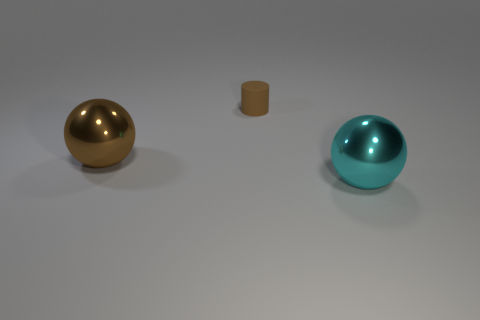What is the color of the metal object that is to the left of the big metallic object that is in front of the large object that is to the left of the big cyan sphere?
Keep it short and to the point. Brown. Are there any other things that are the same color as the matte object?
Your answer should be very brief. Yes. There is another object that is the same color as the small object; what is its shape?
Keep it short and to the point. Sphere. What is the size of the thing that is to the left of the small brown thing?
Your answer should be very brief. Large. There is another thing that is the same size as the cyan metal thing; what is its shape?
Your answer should be compact. Sphere. Does the big ball that is on the right side of the small brown object have the same material as the brown object to the right of the large brown object?
Your answer should be very brief. No. There is a large thing that is on the left side of the cyan sphere that is right of the brown rubber object; what is its material?
Provide a short and direct response. Metal. What is the size of the ball that is on the right side of the large metal thing that is left of the metallic object to the right of the brown shiny ball?
Provide a short and direct response. Large. Do the brown matte cylinder and the brown metal object have the same size?
Provide a short and direct response. No. Does the big object to the right of the small object have the same shape as the large metallic object that is left of the tiny thing?
Keep it short and to the point. Yes. 